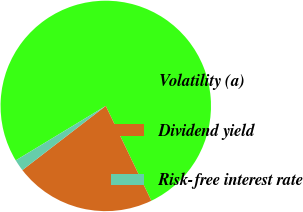Convert chart to OTSL. <chart><loc_0><loc_0><loc_500><loc_500><pie_chart><fcel>Volatility (a)<fcel>Dividend yield<fcel>Risk-free interest rate<nl><fcel>76.53%<fcel>21.69%<fcel>1.78%<nl></chart> 